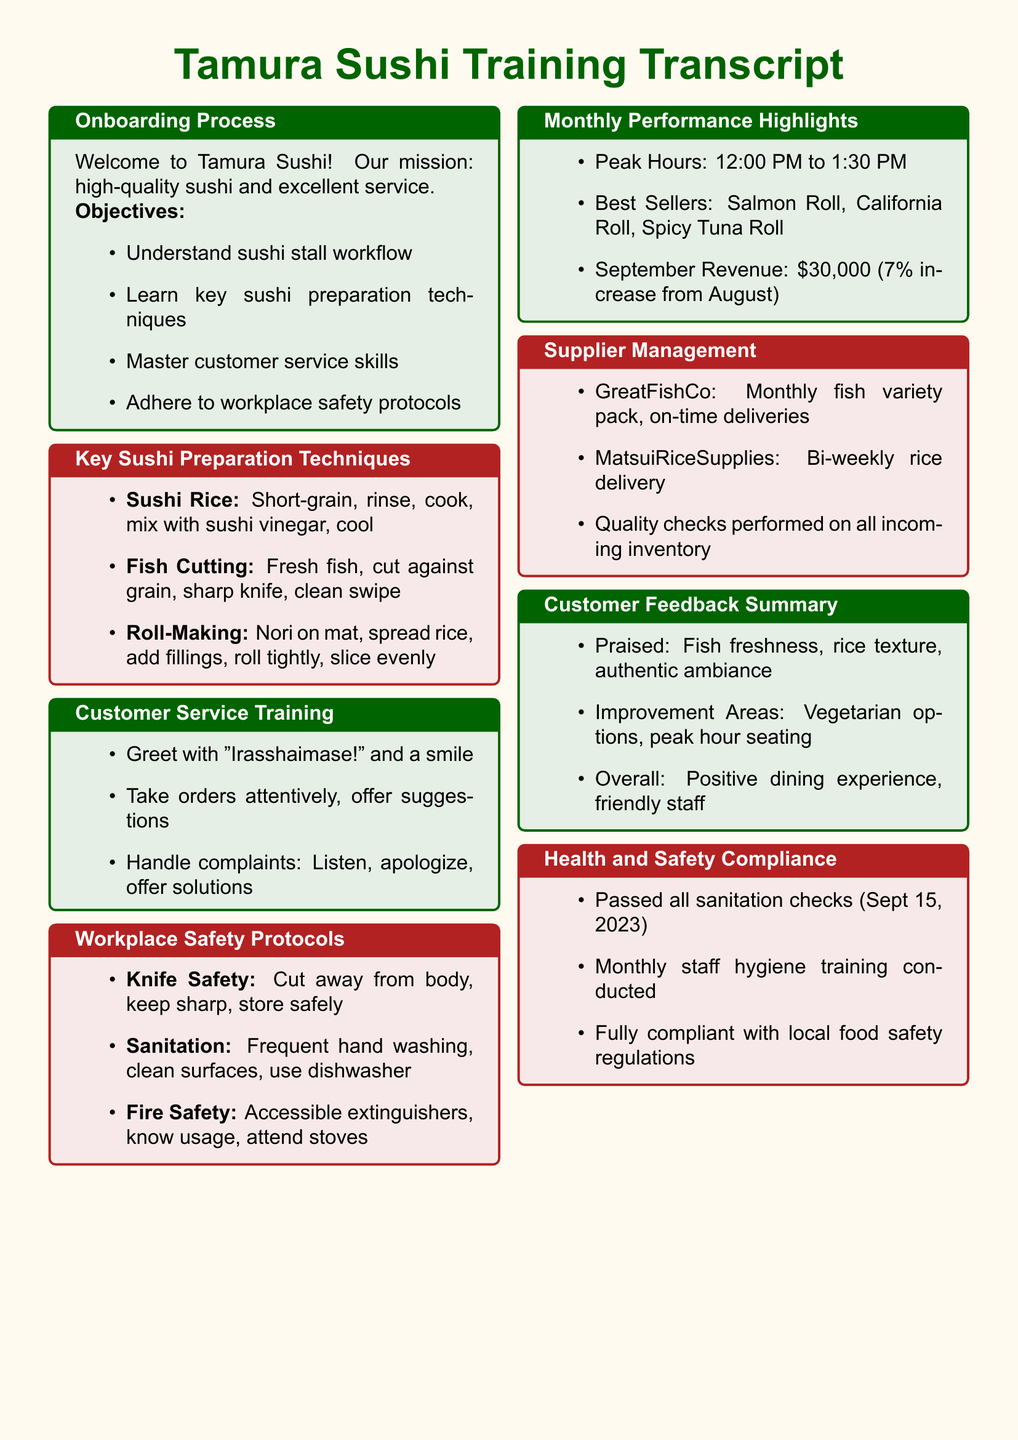What is the mission of Tamura Sushi? The mission is stated clearly at the start of the document, emphasizing high-quality sushi and excellent service.
Answer: high-quality sushi and excellent service What are the peak hours of operation? The peak hours are highlighted in the monthly performance section of the document.
Answer: 12:00 PM to 1:30 PM What is the revenue increase percentage from August to September? The document states that September revenue increased by 7% from August.
Answer: 7% What is the name of the supplier for the fish variety pack? The supplier name is mentioned in the supplier management box.
Answer: GreatFishCo What key area for improvement is identified in customer feedback? The document mentions areas needing improvement based on customer feedback.
Answer: Vegetarian options What is the date of the last passed sanitation check? The last sanitation check date is explicitly mentioned in the health and safety compliance section.
Answer: September 15, 2023 How often are rice deliveries made? The frequency of rice deliveries is specified in the supplier management section.
Answer: Bi-weekly What should employees say when greeting customers? The customer service training section provides guidance on how to greet customers.
Answer: "Irasshaimase!" What is the best-selling sushi item as per the monthly report? The document lists best-selling items, indicating which ones are preferred by customers.
Answer: Salmon Roll 